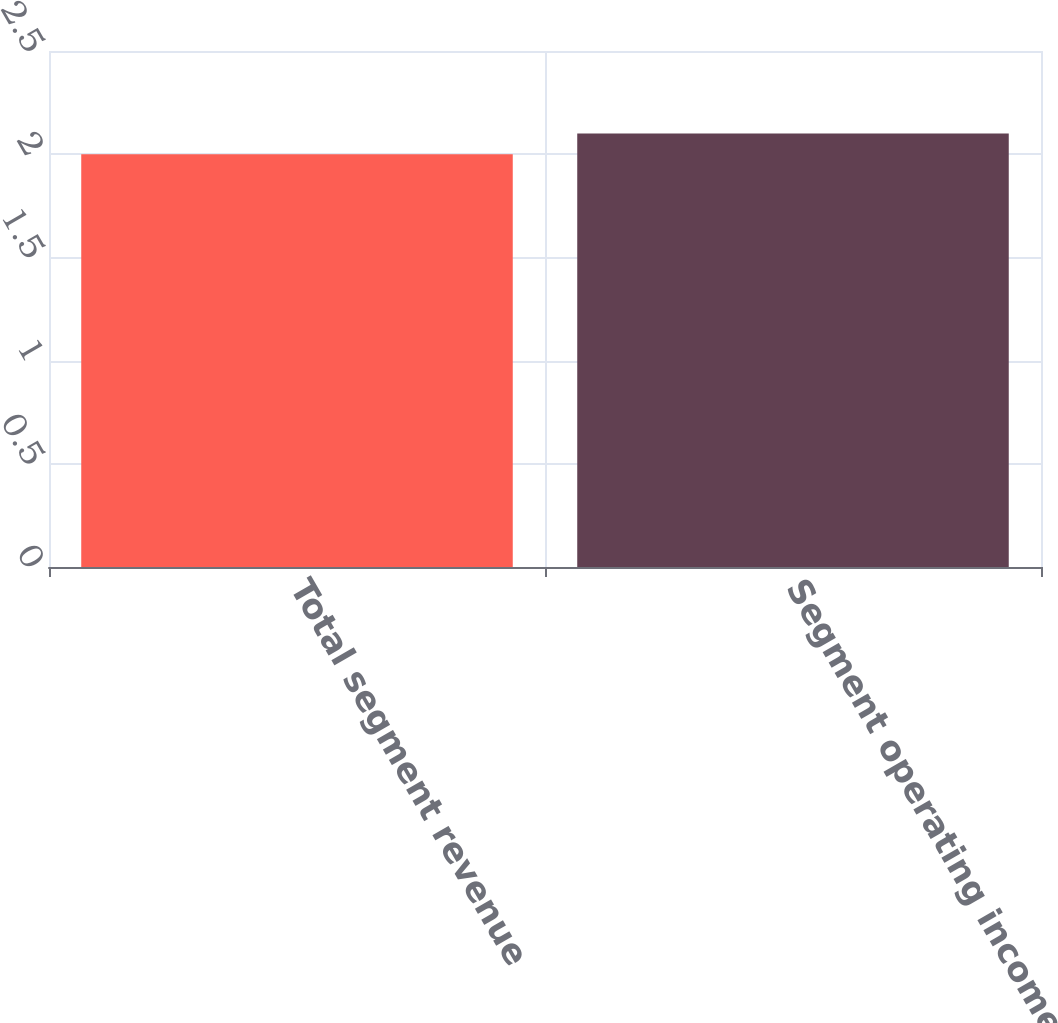<chart> <loc_0><loc_0><loc_500><loc_500><bar_chart><fcel>Total segment revenue<fcel>Segment operating income<nl><fcel>2<fcel>2.1<nl></chart> 